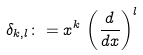Convert formula to latex. <formula><loc_0><loc_0><loc_500><loc_500>\delta _ { k , l } \colon = x ^ { k } \, \left ( \frac { d } { d x } \right ) ^ { l }</formula> 